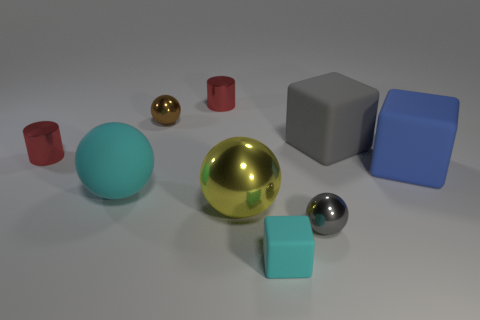Subtract all green balls. Subtract all red cylinders. How many balls are left? 4 Add 1 large blue rubber objects. How many objects exist? 10 Subtract all cylinders. How many objects are left? 7 Add 3 small gray spheres. How many small gray spheres exist? 4 Subtract 0 blue cylinders. How many objects are left? 9 Subtract all tiny red cylinders. Subtract all gray metallic objects. How many objects are left? 6 Add 5 shiny things. How many shiny things are left? 10 